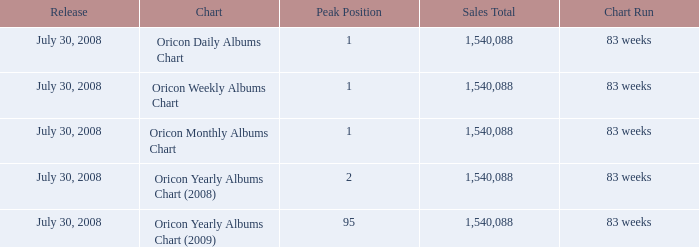Would you be able to parse every entry in this table? {'header': ['Release', 'Chart', 'Peak Position', 'Sales Total', 'Chart Run'], 'rows': [['July 30, 2008', 'Oricon Daily Albums Chart', '1', '1,540,088', '83 weeks'], ['July 30, 2008', 'Oricon Weekly Albums Chart', '1', '1,540,088', '83 weeks'], ['July 30, 2008', 'Oricon Monthly Albums Chart', '1', '1,540,088', '83 weeks'], ['July 30, 2008', 'Oricon Yearly Albums Chart (2008)', '2', '1,540,088', '83 weeks'], ['July 30, 2008', 'Oricon Yearly Albums Chart (2009)', '95', '1,540,088', '83 weeks']]} Which Sales Total has a Chart of oricon monthly albums chart? 1540088.0. 